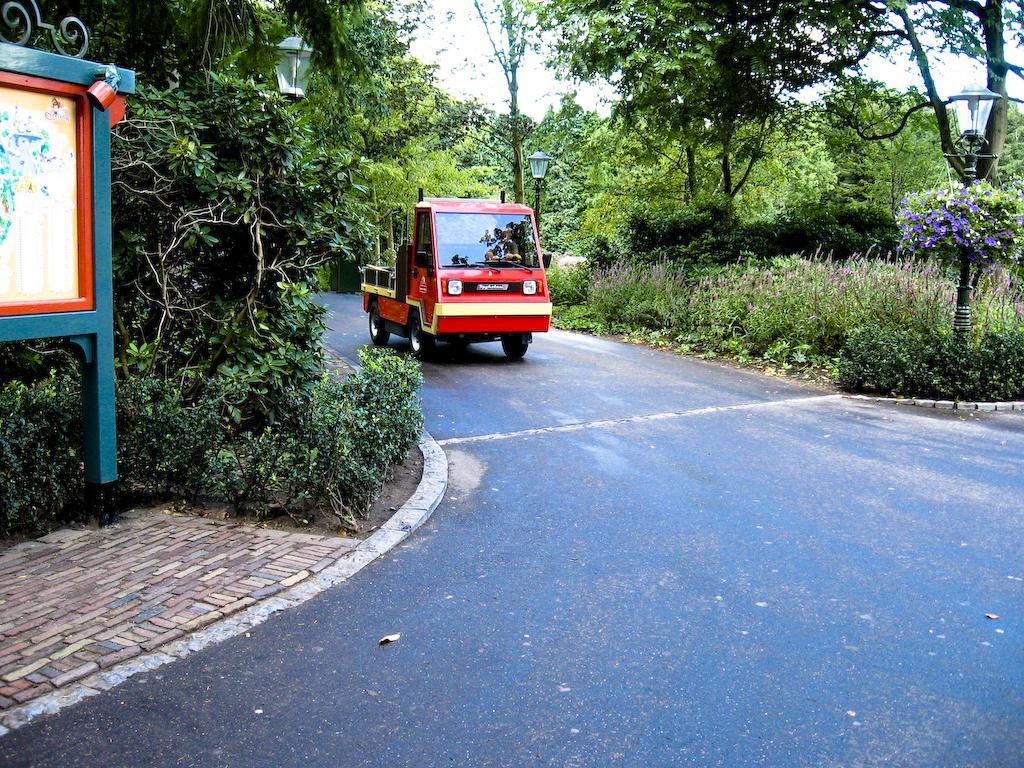In one or two sentences, can you explain what this image depicts? In this image we can see a vehicle on the road and there are few street lights and we can see a board on the left side of the image. We can see some plants, flowers and trees and we can see the sky. 